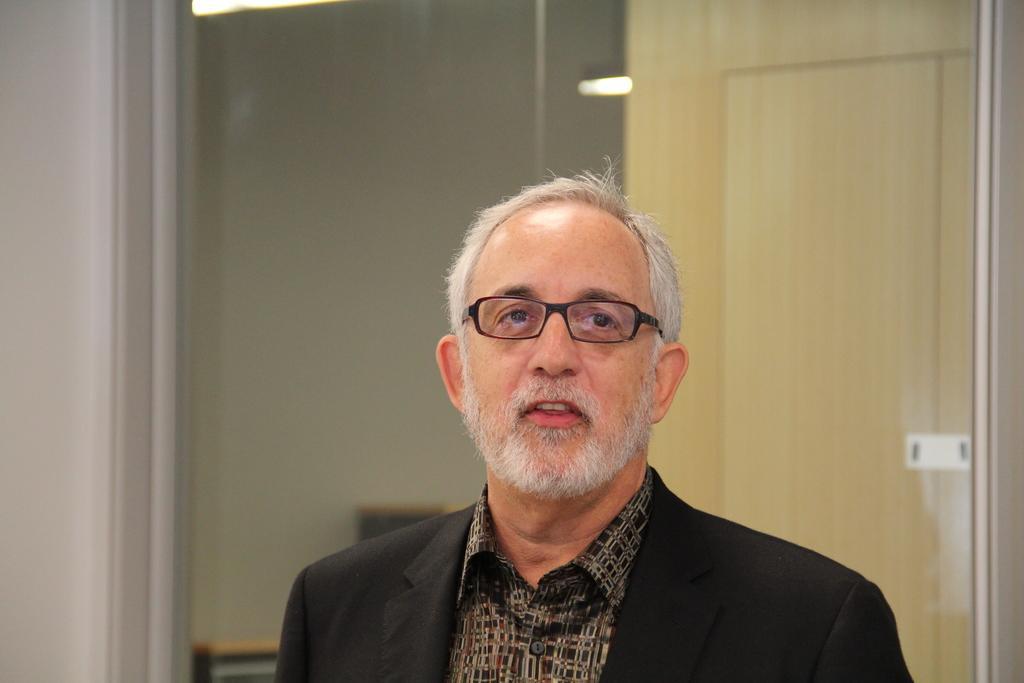Describe this image in one or two sentences. In the center of the image there is a person. Behind him there is a door. There are lights. In the background of the image there is a wall. 